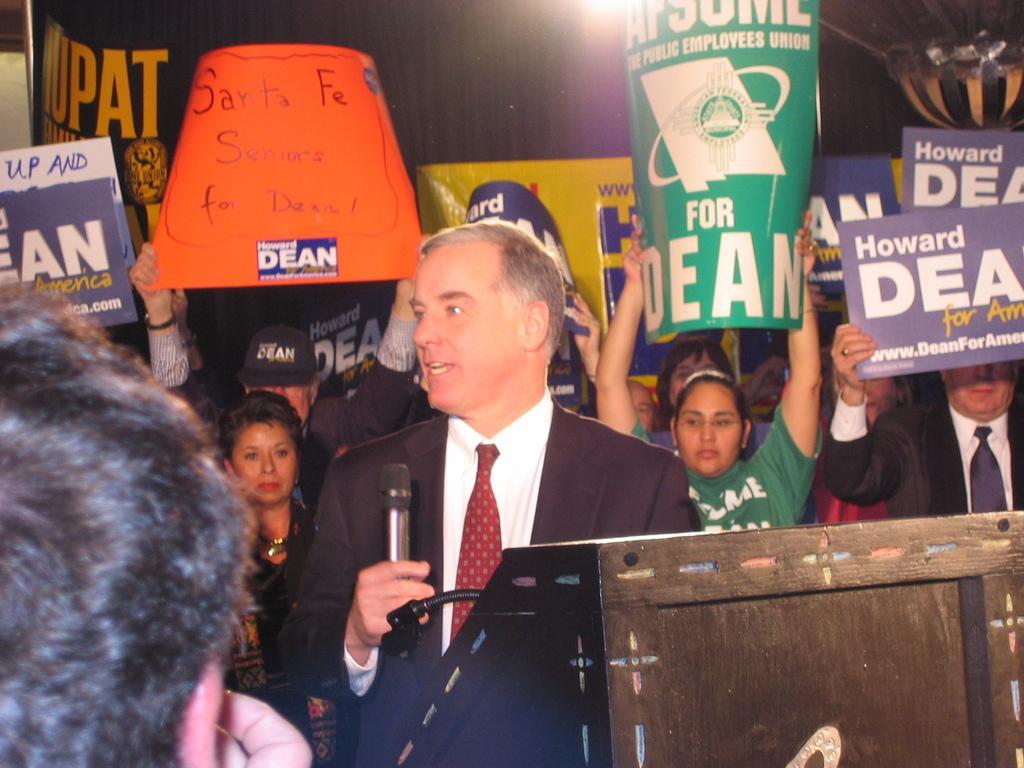Can you describe this image briefly? In the foreground of this image, there is a man standing in front of a podium on which there is a mic stand and he is holding a mic. On the left, there is a head of a person. In the background, there are people standing and holding posters. At the top, there is a light. 